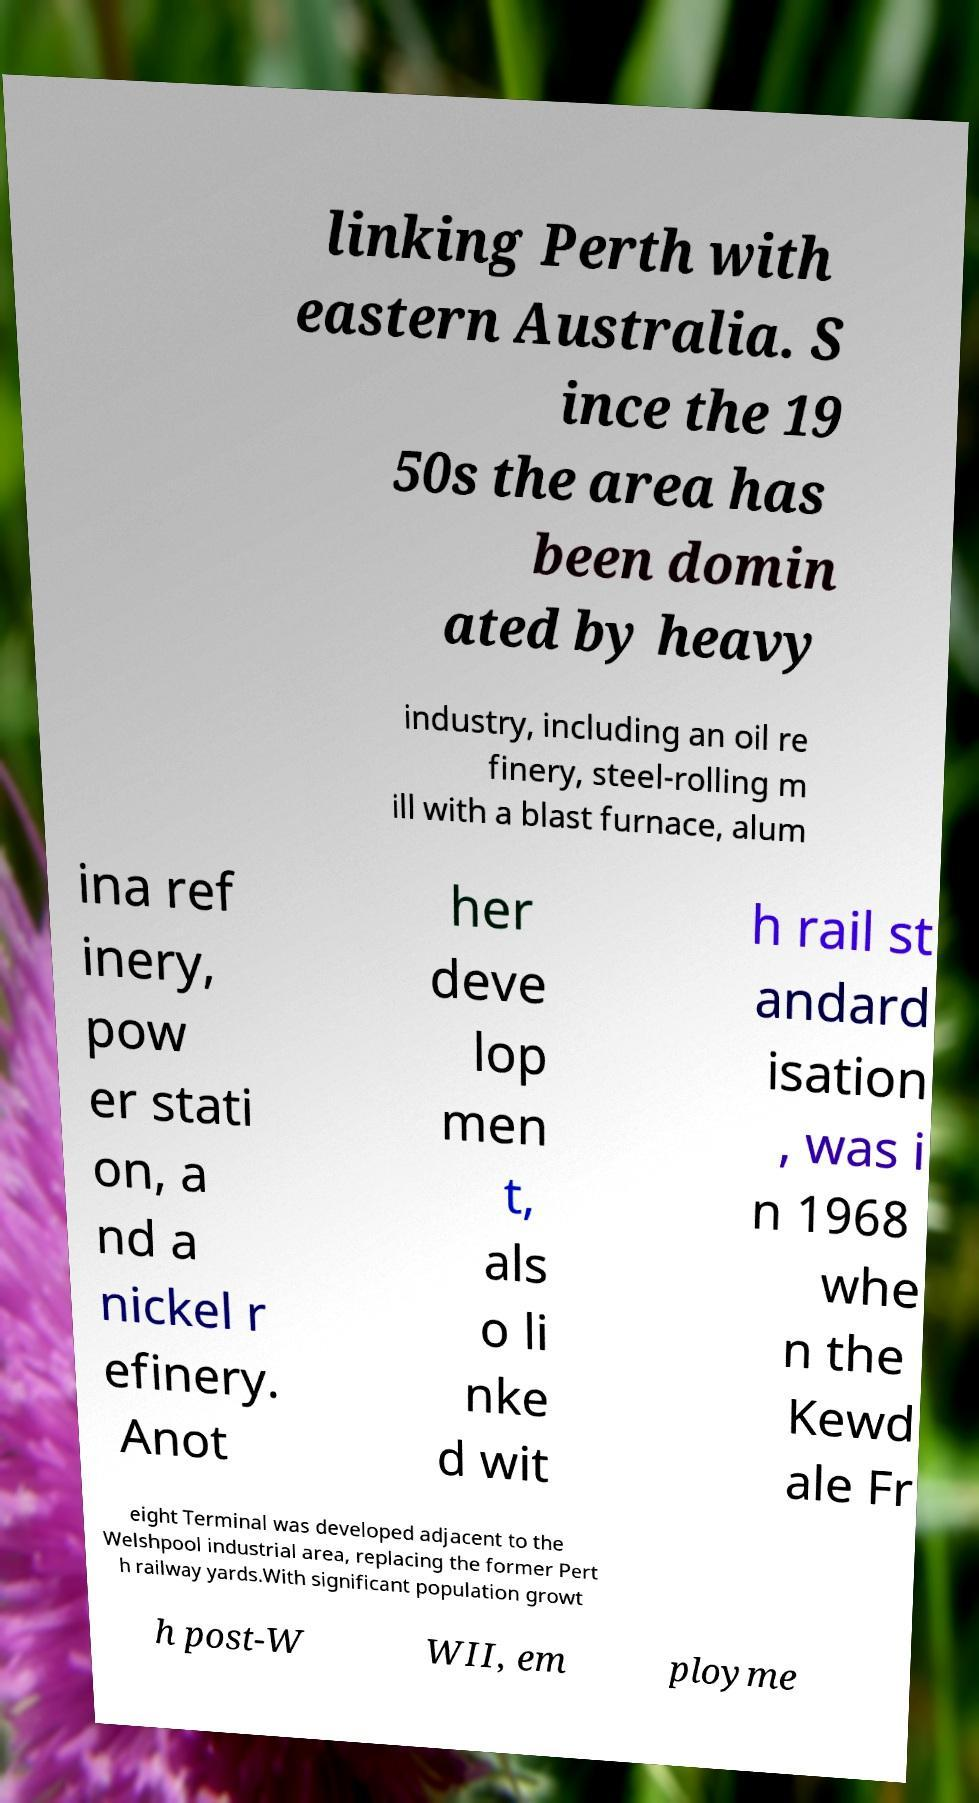Could you assist in decoding the text presented in this image and type it out clearly? linking Perth with eastern Australia. S ince the 19 50s the area has been domin ated by heavy industry, including an oil re finery, steel-rolling m ill with a blast furnace, alum ina ref inery, pow er stati on, a nd a nickel r efinery. Anot her deve lop men t, als o li nke d wit h rail st andard isation , was i n 1968 whe n the Kewd ale Fr eight Terminal was developed adjacent to the Welshpool industrial area, replacing the former Pert h railway yards.With significant population growt h post-W WII, em ployme 